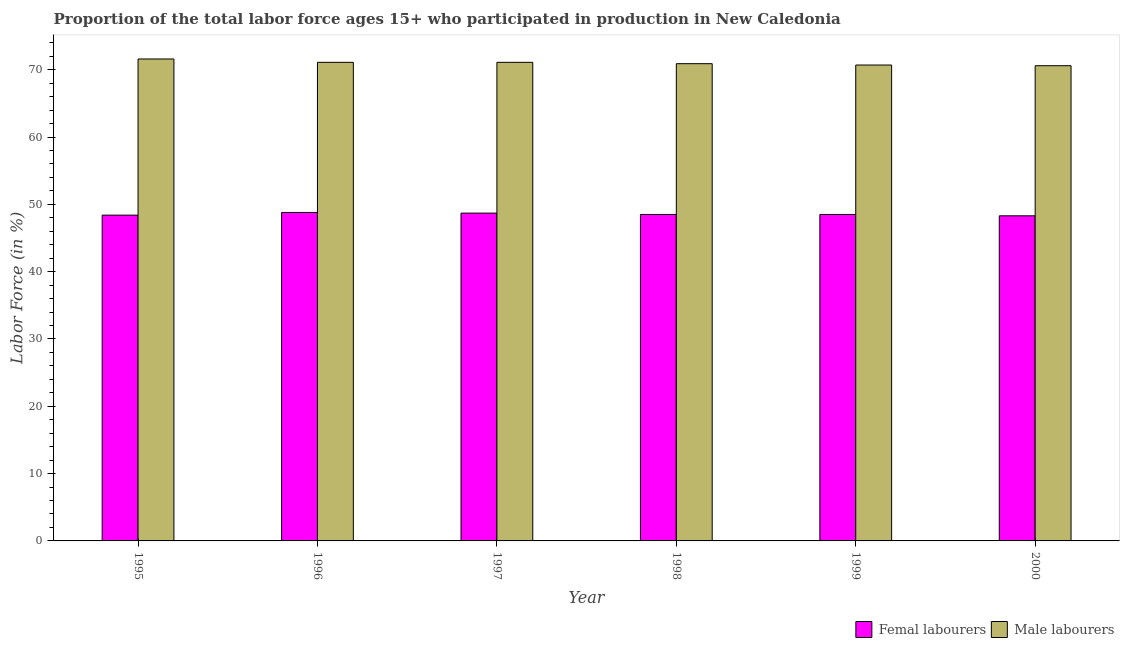How many bars are there on the 1st tick from the right?
Provide a short and direct response. 2. In how many cases, is the number of bars for a given year not equal to the number of legend labels?
Keep it short and to the point. 0. What is the percentage of female labor force in 1999?
Keep it short and to the point. 48.5. Across all years, what is the maximum percentage of female labor force?
Give a very brief answer. 48.8. Across all years, what is the minimum percentage of female labor force?
Provide a short and direct response. 48.3. What is the total percentage of male labour force in the graph?
Provide a succinct answer. 426. What is the difference between the percentage of male labour force in 1995 and that in 1996?
Offer a very short reply. 0.5. What is the difference between the percentage of male labour force in 2000 and the percentage of female labor force in 1998?
Provide a short and direct response. -0.3. What is the average percentage of female labor force per year?
Offer a terse response. 48.53. In the year 1997, what is the difference between the percentage of female labor force and percentage of male labour force?
Ensure brevity in your answer.  0. In how many years, is the percentage of male labour force greater than 56 %?
Your response must be concise. 6. What is the ratio of the percentage of male labour force in 1999 to that in 2000?
Keep it short and to the point. 1. What is the difference between the highest and the second highest percentage of female labor force?
Provide a succinct answer. 0.1. What is the difference between the highest and the lowest percentage of male labour force?
Provide a succinct answer. 1. Is the sum of the percentage of female labor force in 1995 and 2000 greater than the maximum percentage of male labour force across all years?
Provide a succinct answer. Yes. What does the 1st bar from the left in 1996 represents?
Provide a succinct answer. Femal labourers. What does the 1st bar from the right in 1999 represents?
Your response must be concise. Male labourers. How many bars are there?
Keep it short and to the point. 12. What is the title of the graph?
Offer a terse response. Proportion of the total labor force ages 15+ who participated in production in New Caledonia. Does "Researchers" appear as one of the legend labels in the graph?
Offer a very short reply. No. What is the label or title of the X-axis?
Your response must be concise. Year. What is the Labor Force (in %) in Femal labourers in 1995?
Keep it short and to the point. 48.4. What is the Labor Force (in %) in Male labourers in 1995?
Offer a terse response. 71.6. What is the Labor Force (in %) of Femal labourers in 1996?
Your response must be concise. 48.8. What is the Labor Force (in %) in Male labourers in 1996?
Ensure brevity in your answer.  71.1. What is the Labor Force (in %) in Femal labourers in 1997?
Keep it short and to the point. 48.7. What is the Labor Force (in %) of Male labourers in 1997?
Your answer should be compact. 71.1. What is the Labor Force (in %) of Femal labourers in 1998?
Keep it short and to the point. 48.5. What is the Labor Force (in %) in Male labourers in 1998?
Offer a terse response. 70.9. What is the Labor Force (in %) in Femal labourers in 1999?
Your answer should be compact. 48.5. What is the Labor Force (in %) of Male labourers in 1999?
Ensure brevity in your answer.  70.7. What is the Labor Force (in %) in Femal labourers in 2000?
Your answer should be very brief. 48.3. What is the Labor Force (in %) of Male labourers in 2000?
Your answer should be very brief. 70.6. Across all years, what is the maximum Labor Force (in %) in Femal labourers?
Offer a terse response. 48.8. Across all years, what is the maximum Labor Force (in %) in Male labourers?
Offer a terse response. 71.6. Across all years, what is the minimum Labor Force (in %) of Femal labourers?
Give a very brief answer. 48.3. Across all years, what is the minimum Labor Force (in %) of Male labourers?
Offer a very short reply. 70.6. What is the total Labor Force (in %) of Femal labourers in the graph?
Keep it short and to the point. 291.2. What is the total Labor Force (in %) of Male labourers in the graph?
Your answer should be very brief. 426. What is the difference between the Labor Force (in %) in Femal labourers in 1995 and that in 1996?
Keep it short and to the point. -0.4. What is the difference between the Labor Force (in %) in Male labourers in 1995 and that in 1996?
Make the answer very short. 0.5. What is the difference between the Labor Force (in %) in Femal labourers in 1995 and that in 1997?
Offer a very short reply. -0.3. What is the difference between the Labor Force (in %) of Male labourers in 1995 and that in 1997?
Provide a short and direct response. 0.5. What is the difference between the Labor Force (in %) of Femal labourers in 1995 and that in 1998?
Keep it short and to the point. -0.1. What is the difference between the Labor Force (in %) of Male labourers in 1995 and that in 1998?
Provide a succinct answer. 0.7. What is the difference between the Labor Force (in %) in Femal labourers in 1995 and that in 1999?
Ensure brevity in your answer.  -0.1. What is the difference between the Labor Force (in %) of Femal labourers in 1995 and that in 2000?
Provide a succinct answer. 0.1. What is the difference between the Labor Force (in %) in Femal labourers in 1996 and that in 1997?
Offer a terse response. 0.1. What is the difference between the Labor Force (in %) in Femal labourers in 1996 and that in 1998?
Your response must be concise. 0.3. What is the difference between the Labor Force (in %) of Male labourers in 1996 and that in 2000?
Give a very brief answer. 0.5. What is the difference between the Labor Force (in %) in Femal labourers in 1997 and that in 2000?
Offer a very short reply. 0.4. What is the difference between the Labor Force (in %) in Male labourers in 1997 and that in 2000?
Provide a succinct answer. 0.5. What is the difference between the Labor Force (in %) in Male labourers in 1998 and that in 1999?
Your answer should be compact. 0.2. What is the difference between the Labor Force (in %) of Male labourers in 1999 and that in 2000?
Your answer should be compact. 0.1. What is the difference between the Labor Force (in %) of Femal labourers in 1995 and the Labor Force (in %) of Male labourers in 1996?
Make the answer very short. -22.7. What is the difference between the Labor Force (in %) in Femal labourers in 1995 and the Labor Force (in %) in Male labourers in 1997?
Give a very brief answer. -22.7. What is the difference between the Labor Force (in %) of Femal labourers in 1995 and the Labor Force (in %) of Male labourers in 1998?
Your answer should be very brief. -22.5. What is the difference between the Labor Force (in %) of Femal labourers in 1995 and the Labor Force (in %) of Male labourers in 1999?
Make the answer very short. -22.3. What is the difference between the Labor Force (in %) of Femal labourers in 1995 and the Labor Force (in %) of Male labourers in 2000?
Offer a terse response. -22.2. What is the difference between the Labor Force (in %) of Femal labourers in 1996 and the Labor Force (in %) of Male labourers in 1997?
Your answer should be very brief. -22.3. What is the difference between the Labor Force (in %) in Femal labourers in 1996 and the Labor Force (in %) in Male labourers in 1998?
Your response must be concise. -22.1. What is the difference between the Labor Force (in %) of Femal labourers in 1996 and the Labor Force (in %) of Male labourers in 1999?
Make the answer very short. -21.9. What is the difference between the Labor Force (in %) in Femal labourers in 1996 and the Labor Force (in %) in Male labourers in 2000?
Make the answer very short. -21.8. What is the difference between the Labor Force (in %) in Femal labourers in 1997 and the Labor Force (in %) in Male labourers in 1998?
Offer a very short reply. -22.2. What is the difference between the Labor Force (in %) of Femal labourers in 1997 and the Labor Force (in %) of Male labourers in 2000?
Make the answer very short. -21.9. What is the difference between the Labor Force (in %) of Femal labourers in 1998 and the Labor Force (in %) of Male labourers in 1999?
Provide a short and direct response. -22.2. What is the difference between the Labor Force (in %) of Femal labourers in 1998 and the Labor Force (in %) of Male labourers in 2000?
Provide a succinct answer. -22.1. What is the difference between the Labor Force (in %) in Femal labourers in 1999 and the Labor Force (in %) in Male labourers in 2000?
Make the answer very short. -22.1. What is the average Labor Force (in %) of Femal labourers per year?
Provide a succinct answer. 48.53. In the year 1995, what is the difference between the Labor Force (in %) of Femal labourers and Labor Force (in %) of Male labourers?
Offer a terse response. -23.2. In the year 1996, what is the difference between the Labor Force (in %) of Femal labourers and Labor Force (in %) of Male labourers?
Offer a terse response. -22.3. In the year 1997, what is the difference between the Labor Force (in %) of Femal labourers and Labor Force (in %) of Male labourers?
Ensure brevity in your answer.  -22.4. In the year 1998, what is the difference between the Labor Force (in %) of Femal labourers and Labor Force (in %) of Male labourers?
Offer a terse response. -22.4. In the year 1999, what is the difference between the Labor Force (in %) of Femal labourers and Labor Force (in %) of Male labourers?
Make the answer very short. -22.2. In the year 2000, what is the difference between the Labor Force (in %) in Femal labourers and Labor Force (in %) in Male labourers?
Your answer should be compact. -22.3. What is the ratio of the Labor Force (in %) in Femal labourers in 1995 to that in 1996?
Your answer should be very brief. 0.99. What is the ratio of the Labor Force (in %) in Male labourers in 1995 to that in 1996?
Your response must be concise. 1.01. What is the ratio of the Labor Force (in %) in Femal labourers in 1995 to that in 1997?
Make the answer very short. 0.99. What is the ratio of the Labor Force (in %) in Male labourers in 1995 to that in 1997?
Make the answer very short. 1.01. What is the ratio of the Labor Force (in %) of Male labourers in 1995 to that in 1998?
Your answer should be compact. 1.01. What is the ratio of the Labor Force (in %) of Male labourers in 1995 to that in 1999?
Offer a terse response. 1.01. What is the ratio of the Labor Force (in %) of Femal labourers in 1995 to that in 2000?
Ensure brevity in your answer.  1. What is the ratio of the Labor Force (in %) of Male labourers in 1995 to that in 2000?
Make the answer very short. 1.01. What is the ratio of the Labor Force (in %) of Male labourers in 1996 to that in 1998?
Your answer should be very brief. 1. What is the ratio of the Labor Force (in %) of Femal labourers in 1996 to that in 1999?
Offer a very short reply. 1.01. What is the ratio of the Labor Force (in %) of Femal labourers in 1996 to that in 2000?
Offer a very short reply. 1.01. What is the ratio of the Labor Force (in %) in Male labourers in 1996 to that in 2000?
Keep it short and to the point. 1.01. What is the ratio of the Labor Force (in %) of Femal labourers in 1997 to that in 1998?
Provide a succinct answer. 1. What is the ratio of the Labor Force (in %) of Male labourers in 1997 to that in 1999?
Your answer should be very brief. 1.01. What is the ratio of the Labor Force (in %) of Femal labourers in 1997 to that in 2000?
Give a very brief answer. 1.01. What is the ratio of the Labor Force (in %) of Male labourers in 1997 to that in 2000?
Offer a very short reply. 1.01. What is the ratio of the Labor Force (in %) of Femal labourers in 1999 to that in 2000?
Your answer should be compact. 1. What is the ratio of the Labor Force (in %) in Male labourers in 1999 to that in 2000?
Offer a terse response. 1. What is the difference between the highest and the second highest Labor Force (in %) of Femal labourers?
Give a very brief answer. 0.1. What is the difference between the highest and the second highest Labor Force (in %) in Male labourers?
Give a very brief answer. 0.5. What is the difference between the highest and the lowest Labor Force (in %) of Femal labourers?
Offer a terse response. 0.5. 